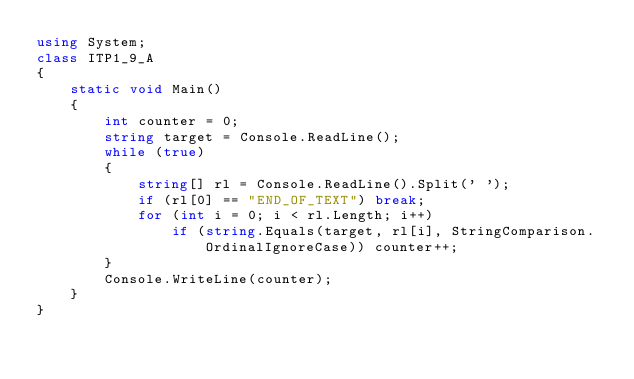<code> <loc_0><loc_0><loc_500><loc_500><_C#_>using System;
class ITP1_9_A
{
    static void Main()
    {
        int counter = 0;
        string target = Console.ReadLine();
        while (true)
        {
            string[] rl = Console.ReadLine().Split(' ');
            if (rl[0] == "END_OF_TEXT") break;
            for (int i = 0; i < rl.Length; i++)
                if (string.Equals(target, rl[i], StringComparison.OrdinalIgnoreCase)) counter++;
        }
        Console.WriteLine(counter);
    }
}</code> 